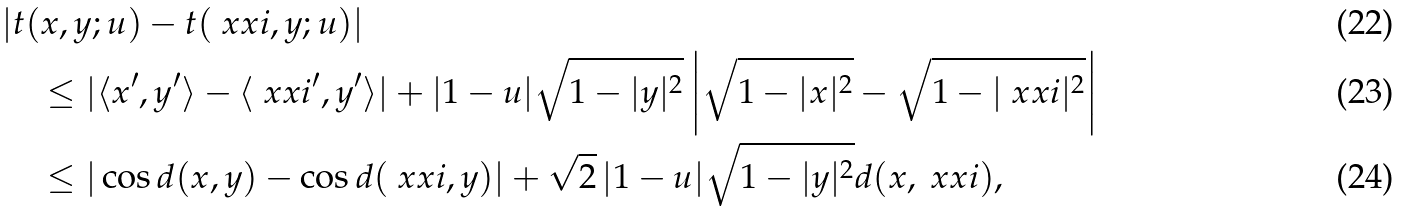<formula> <loc_0><loc_0><loc_500><loc_500>& | t ( x , y ; u ) - t ( \ x x i , y ; u ) | \\ & \quad \leq | \langle x ^ { \prime } , y ^ { \prime } \rangle - \langle \ x x i ^ { \prime } , y ^ { \prime } \rangle | + | 1 - u | \sqrt { 1 - | y | ^ { 2 } } \left | \sqrt { 1 - | x | ^ { 2 } } - \sqrt { 1 - | \ x x i | ^ { 2 } } \right | \\ & \quad \leq | \cos d ( x , y ) - \cos d ( \ x x i , y ) | + \sqrt { 2 } \, | 1 - u | \sqrt { 1 - | y | ^ { 2 } } d ( x , \ x x i ) ,</formula> 